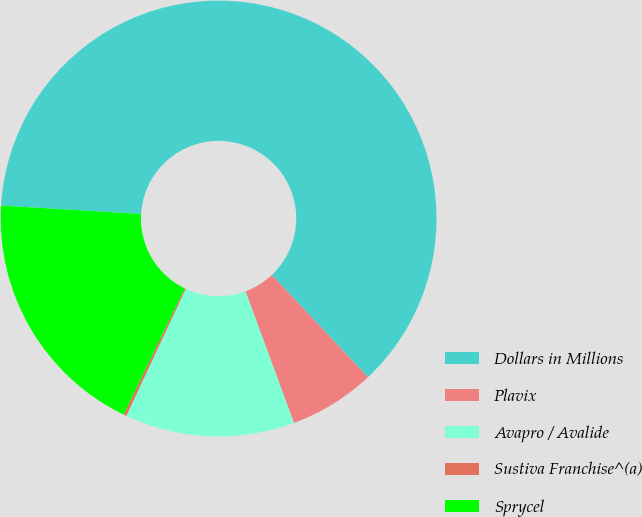<chart> <loc_0><loc_0><loc_500><loc_500><pie_chart><fcel>Dollars in Millions<fcel>Plavix<fcel>Avapro / Avalide<fcel>Sustiva Franchise^(a)<fcel>Sprycel<nl><fcel>62.04%<fcel>6.4%<fcel>12.58%<fcel>0.22%<fcel>18.76%<nl></chart> 